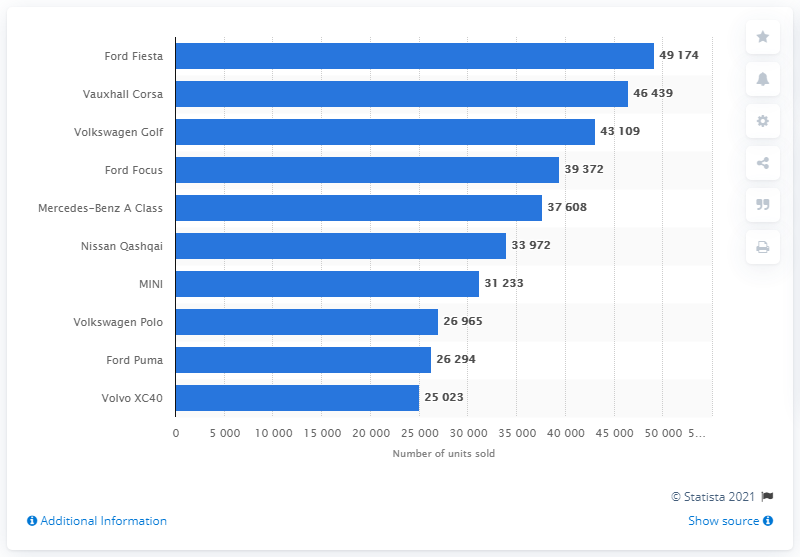Outline some significant characteristics in this image. The Ford Fiesta was the best-selling car model in 2020. 